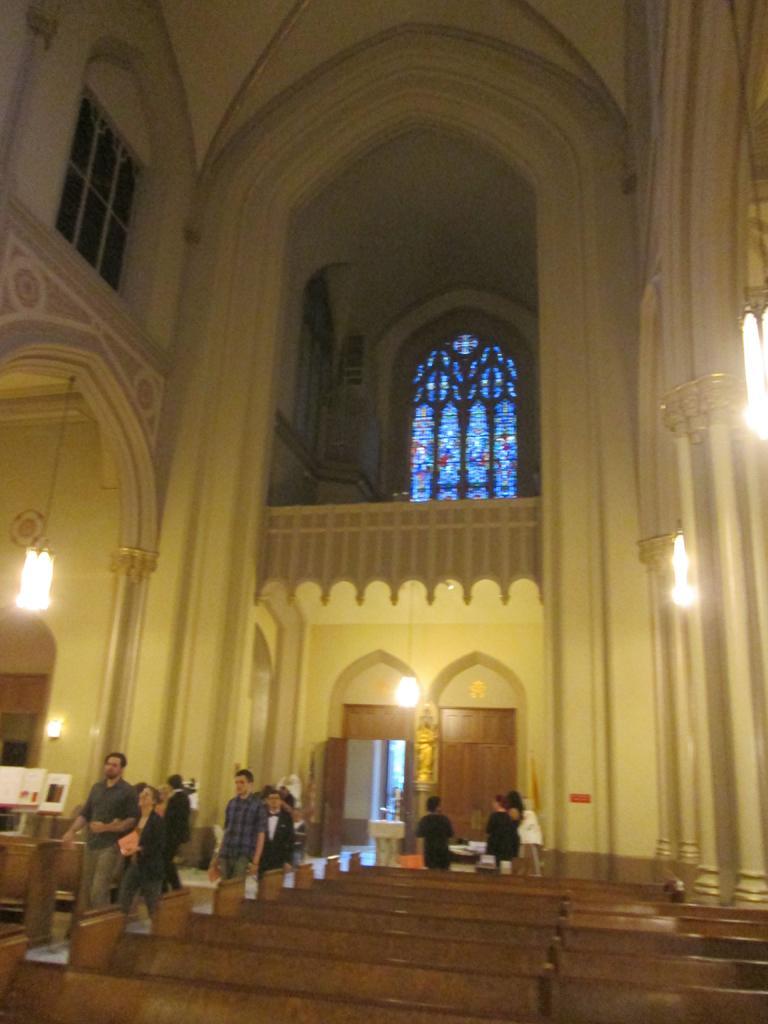Can you describe this image briefly? In this picture we can see benches, some people on the floor and in the background we can see boards, lights, doors, windows, statue and some objects. 